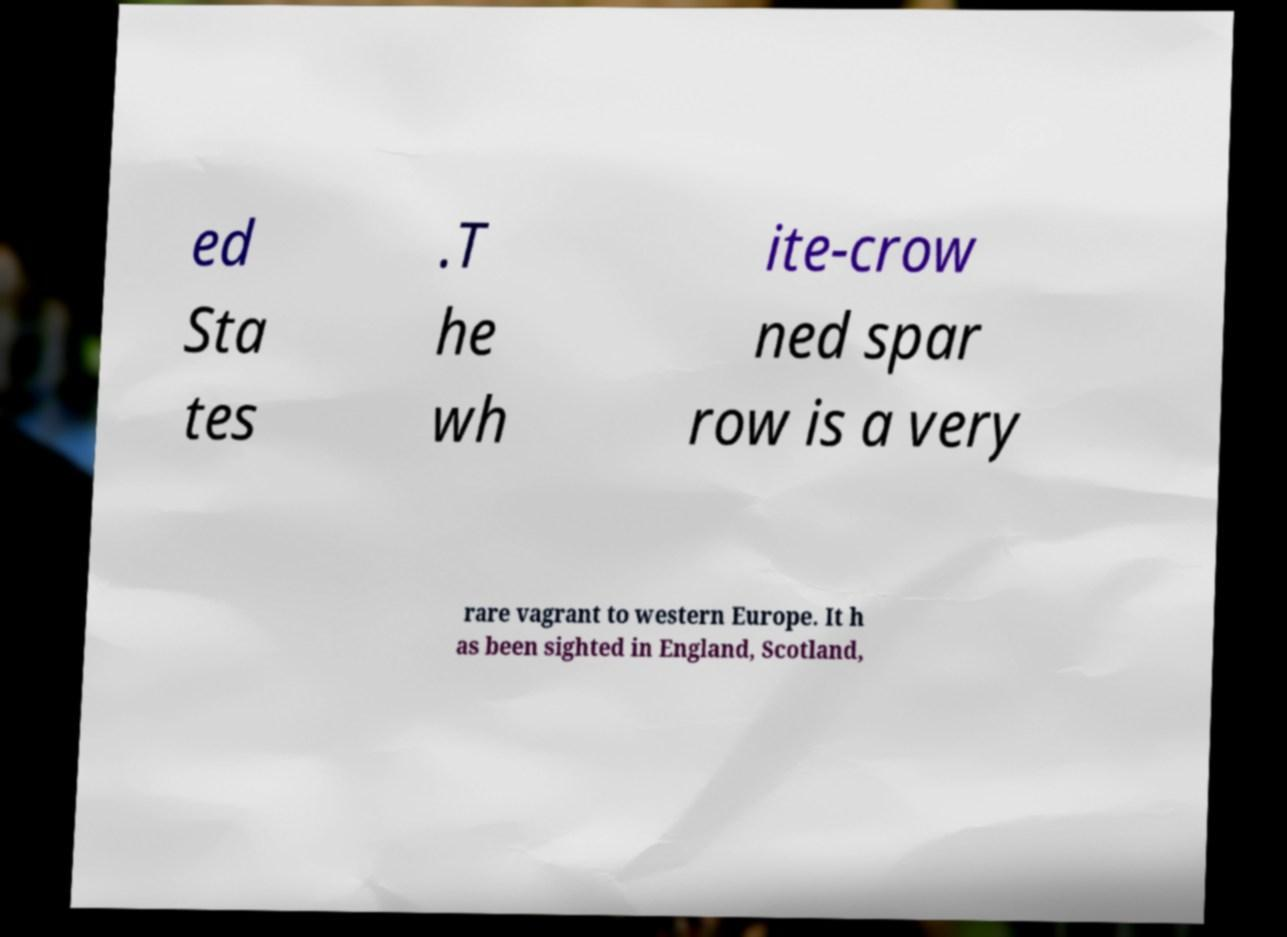Can you read and provide the text displayed in the image?This photo seems to have some interesting text. Can you extract and type it out for me? ed Sta tes .T he wh ite-crow ned spar row is a very rare vagrant to western Europe. It h as been sighted in England, Scotland, 